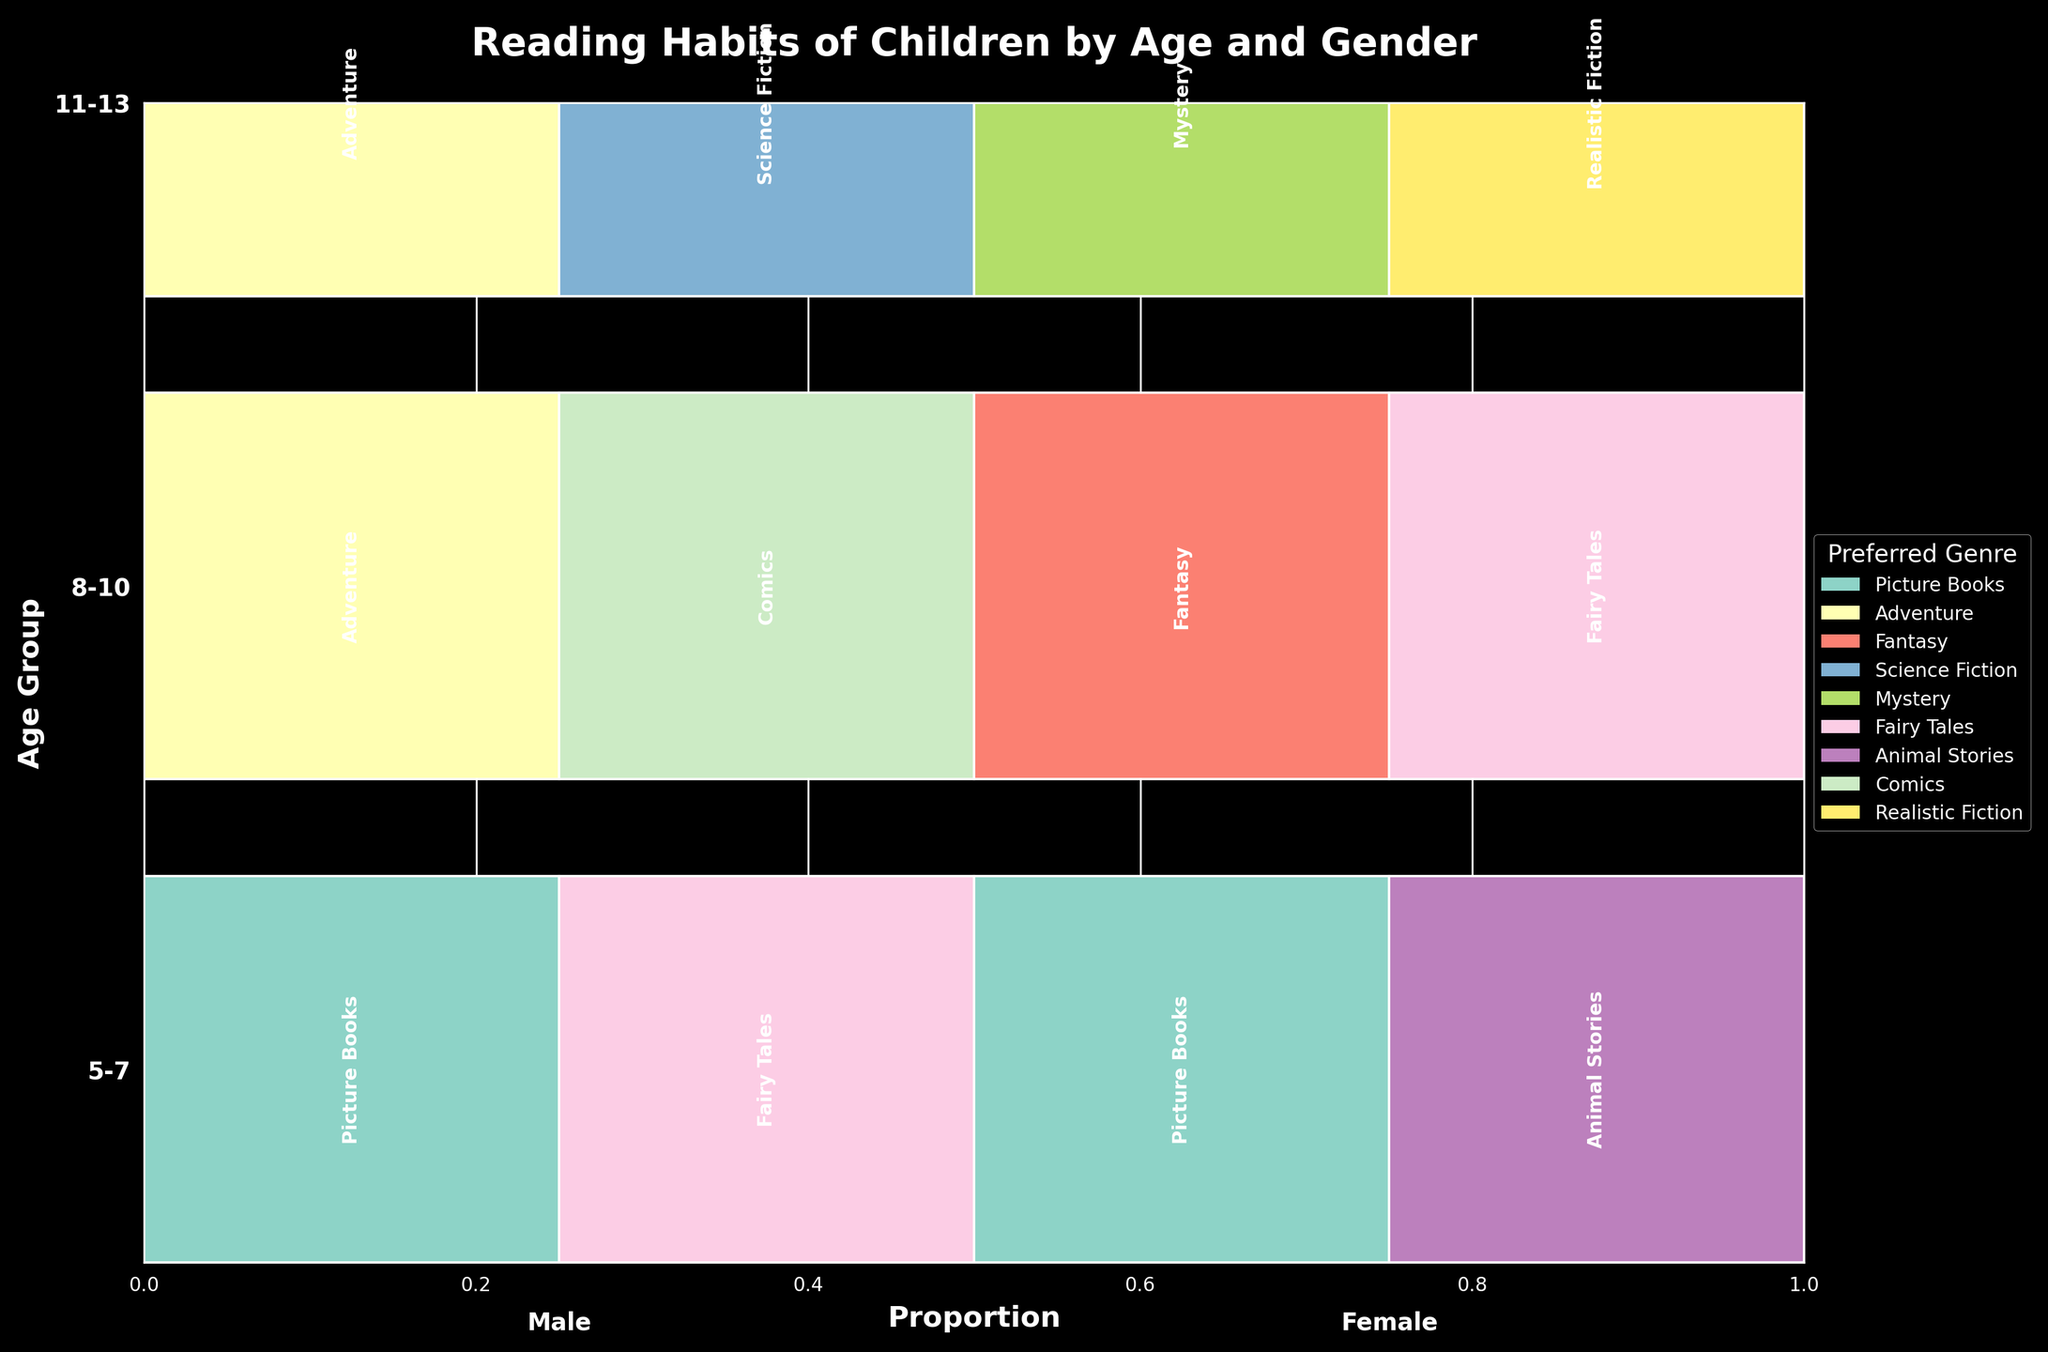What is the title of the figure? The title is generally located at the top of the figure and is the largest text, it helps to understand the context of the visualization.
Answer: Reading Habits of Children by Age and Gender Which age group reads Picture Books daily? To determine this, look for the section labeled "Picture Books" within the rows corresponding to each age group, and identify if the rectangle has significant width in the "Daily" frequency section.
Answer: 5-7 Which gender has a higher frequency of reading Adventure books in the 11-13 age group? In the row for the 11-13 age group, compare the widths of rectangles labeled "Adventure" for both male and female sections. The gender with the wider rectangle reads more frequently.
Answer: Male Out of the 8-10 age group, what is the most frequently read genre among males? Observe the row for the 8-10 age group and focus on the male sections. Identify the label within the male section with the widest proportion.
Answer: Comics Compare the reading frequency of Fairy Tales between the 5-7 and 8-10 age groups. Which age group reads it more frequently? Check the rectangles labeled "Fairy Tales" in rows for 5-7 and 8-10 age groups. Compare the widths of these rectangles to determine which is larger.
Answer: 5-7 What genre is read daily by females in the 11-13 age group? Identify the row for the 11-13 age group and look for sections labeled "Daily" to find the corresponding genre in the female section.
Answer: Mystery What is the proportion of daily reading for animal stories in the 5-7 age group among females? Find the "Animal Stories" rectangle in the 5-7 age group for females and check its width relative to the total row width. It should be significant for the "Daily" frequency section.
Answer: Likely near 0.5 (half) Which age group shows the widest variety of preferred genres? Compare the number of distinct genres present within each age group's rows. The age group with the most distinct genres has the widest variety.
Answer: 5-7 In the 11-13 age group, which genre is read weekly by males? Look in the row for the 11-13 age group and identify the labeled genre in the male section that matches the "Weekly" frequency.
Answer: Science Fiction For Adventure genre, how does the reading frequency compare between males in the 8-10 and 11-13 age groups? Identify the "Adventure" rectangles in both age groups for males and compare their widths. The wider the rectangle, the higher the reading frequency.
Answer: 11-13 reads more frequently 